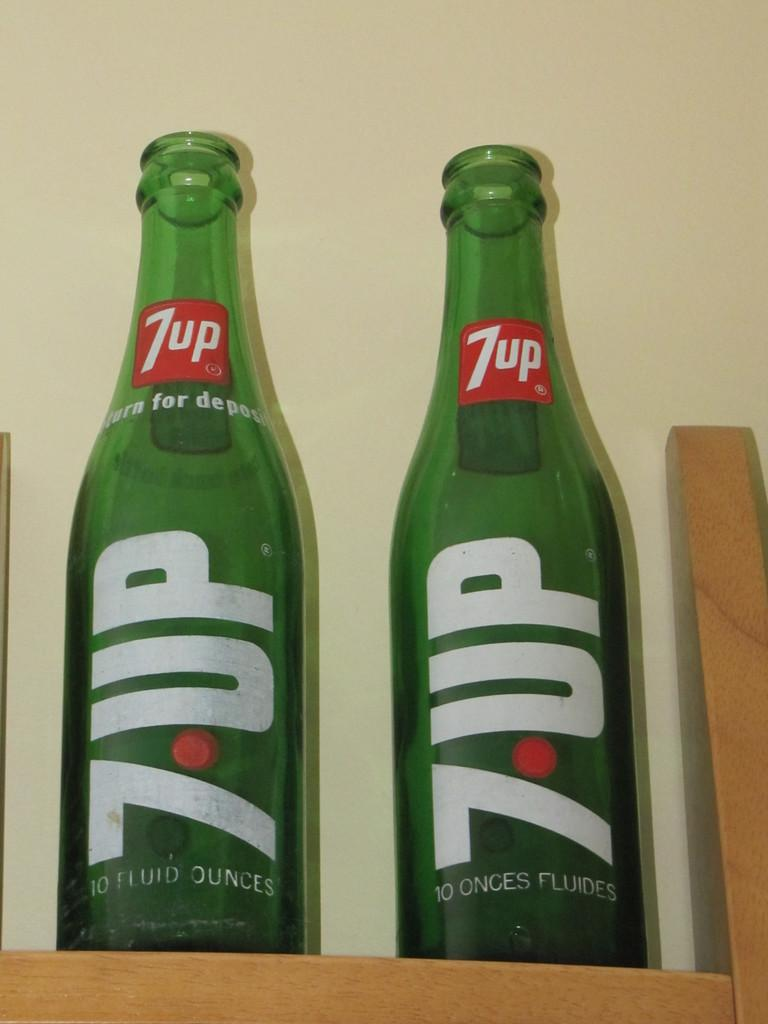How many green bottles are in the image? There are two green bottles in the image. What are the bottles placed on? The bottles are on a brown stand. Is the stand visible in the image? Yes, the stand is visible in the image. What can be seen in the background of the image? There is a wall in the background of the image. What color is the wall? The wall is in a cream color. What type of stocking is hanging on the wall in the image? There is no stocking hanging on the wall in the image. Can you see the person's breath in the image? There is no indication of breath in the image, as it is a still image of bottles and a wall. 